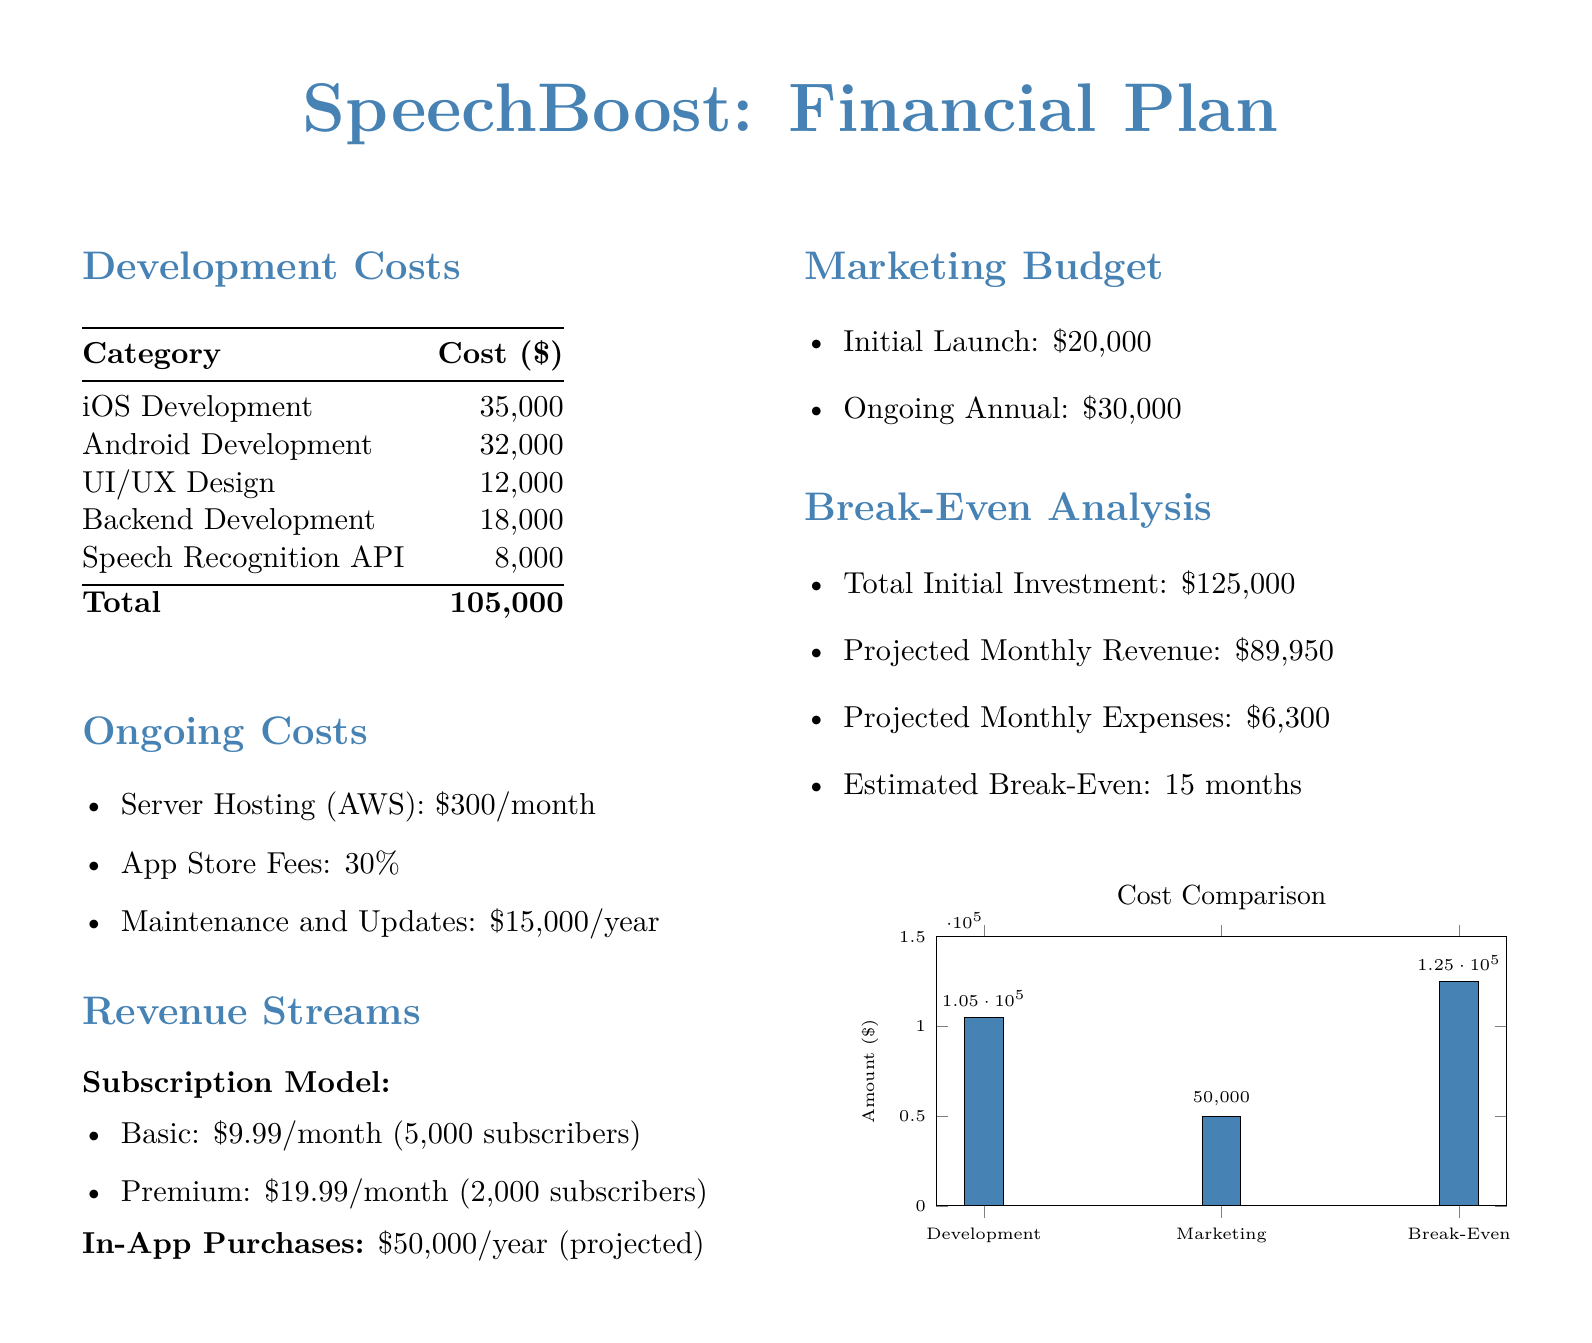what is the total development cost? The total development cost is listed as $105,000 in the document.
Answer: $105,000 what is the monthly server hosting cost? The server hosting cost per month is specified as $300 in the document.
Answer: $300 how many subscribers are projected for the basic subscription? The document states there are 5,000 projected subscribers for the basic subscription.
Answer: 5,000 what is the annual maintenance and updates cost? The cost for maintenance and updates per year is indicated as $15,000 in the document.
Answer: $15,000 what percentage of the revenue goes to App Store fees? The document specifies that App Store fees are 30%.
Answer: 30% how much revenue is projected from in-app purchases? The anticipated revenue from in-app purchases is noted as $50,000 per year.
Answer: $50,000 what is the initial marketing budget? The initial marketing budget is stated as $20,000 in the document.
Answer: $20,000 what is the estimated break-even time in months? The estimated break-even period is mentioned to be 15 months in the document.
Answer: 15 months what is the total initial investment? The total initial investment required is presented as $125,000 in the document.
Answer: $125,000 what is the projected monthly revenue? The document states that the projected monthly revenue is $89,950.
Answer: $89,950 